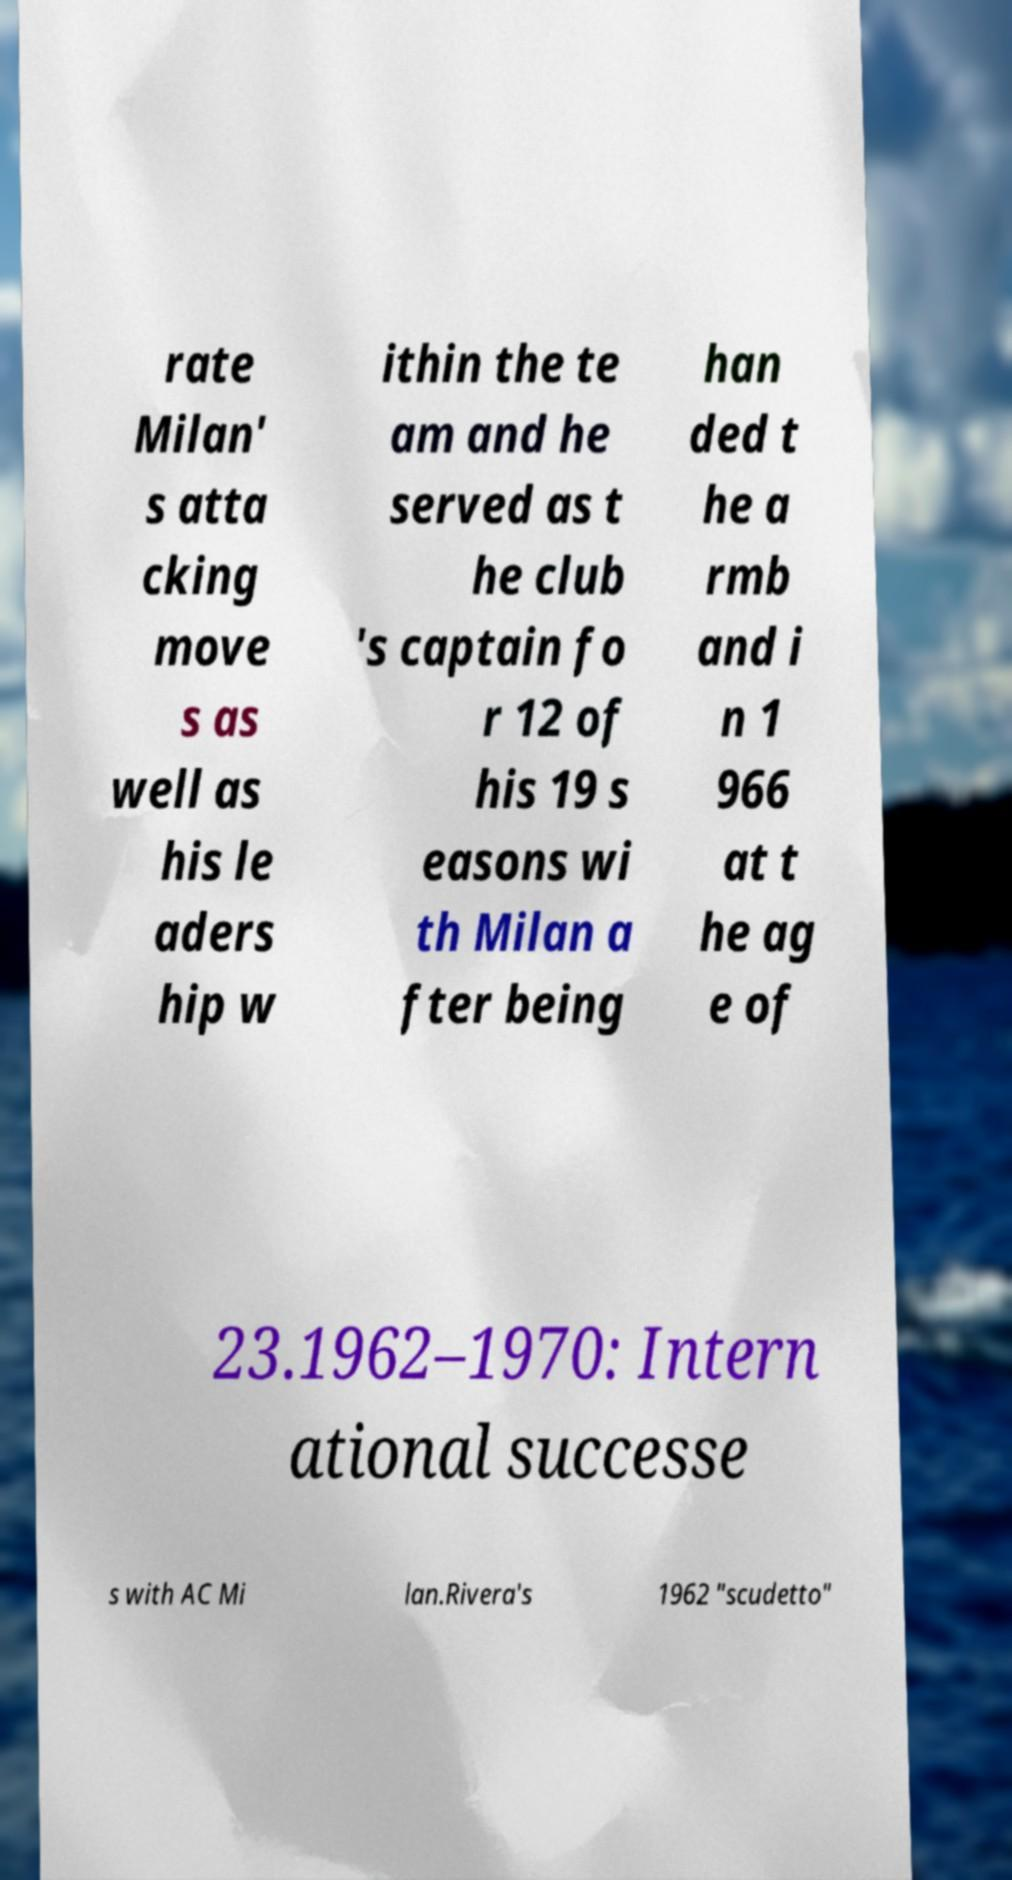Could you extract and type out the text from this image? rate Milan' s atta cking move s as well as his le aders hip w ithin the te am and he served as t he club 's captain fo r 12 of his 19 s easons wi th Milan a fter being han ded t he a rmb and i n 1 966 at t he ag e of 23.1962–1970: Intern ational successe s with AC Mi lan.Rivera's 1962 "scudetto" 